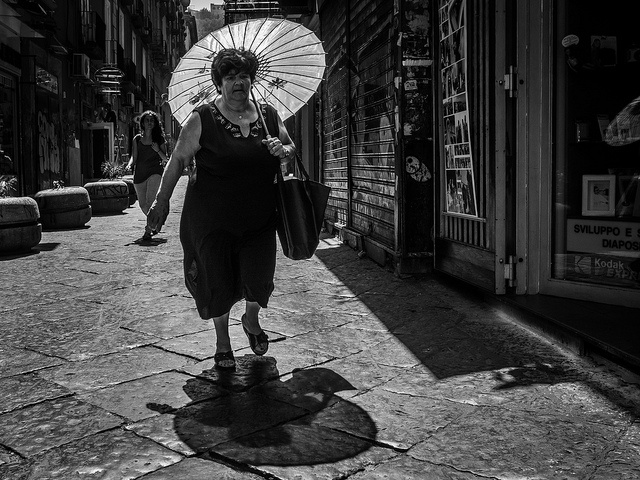Describe the objects in this image and their specific colors. I can see people in black, gray, darkgray, and lightgray tones, umbrella in black, lightgray, darkgray, and gray tones, handbag in black, gray, darkgray, and lightgray tones, people in black, gray, darkgray, and gainsboro tones, and handbag in black, gray, darkgray, and white tones in this image. 